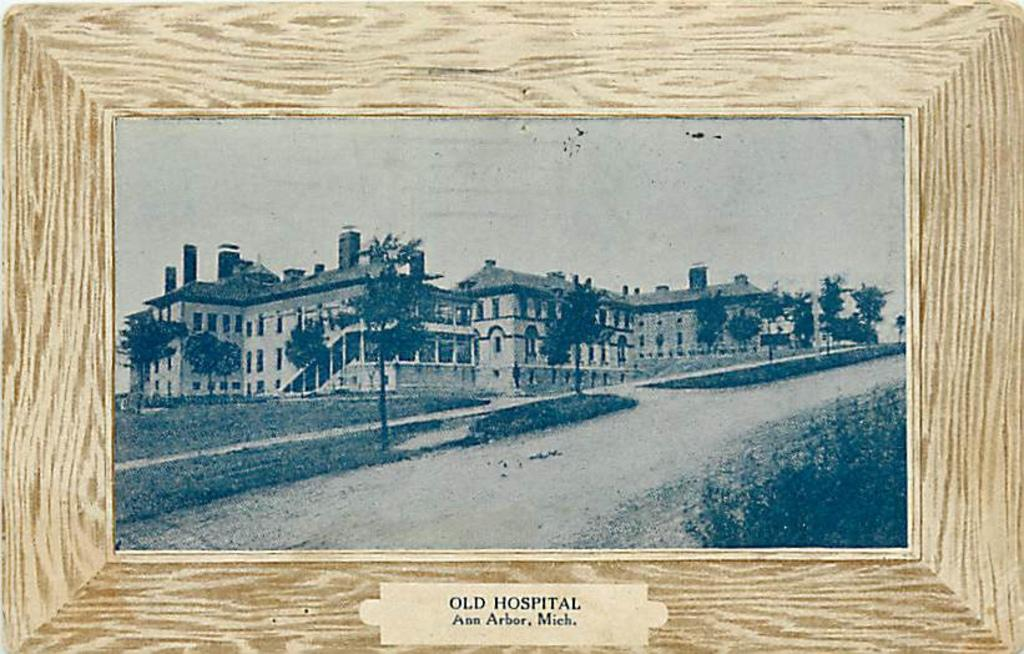<image>
Describe the image concisely. the words Old Hospital are on the frame 